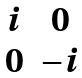Convert formula to latex. <formula><loc_0><loc_0><loc_500><loc_500>\begin{matrix} i & 0 \\ 0 & - i \end{matrix}</formula> 